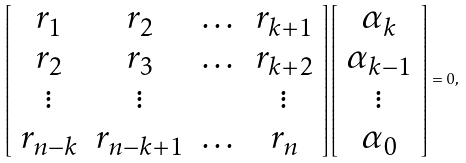Convert formula to latex. <formula><loc_0><loc_0><loc_500><loc_500>\left [ \begin{array} { c c c c } r _ { 1 } & r _ { 2 } & \dots & r _ { k + 1 } \\ r _ { 2 } & r _ { 3 } & \dots & r _ { k + 2 } \\ \vdots & \vdots & & \vdots \\ r _ { n - k } & r _ { n - k + 1 } & \dots & r _ { n } \end{array} \right ] \left [ \begin{array} { c } \alpha _ { k } \\ \alpha _ { k - 1 } \\ \vdots \\ \alpha _ { 0 } \end{array} \right ] = 0 ,</formula> 